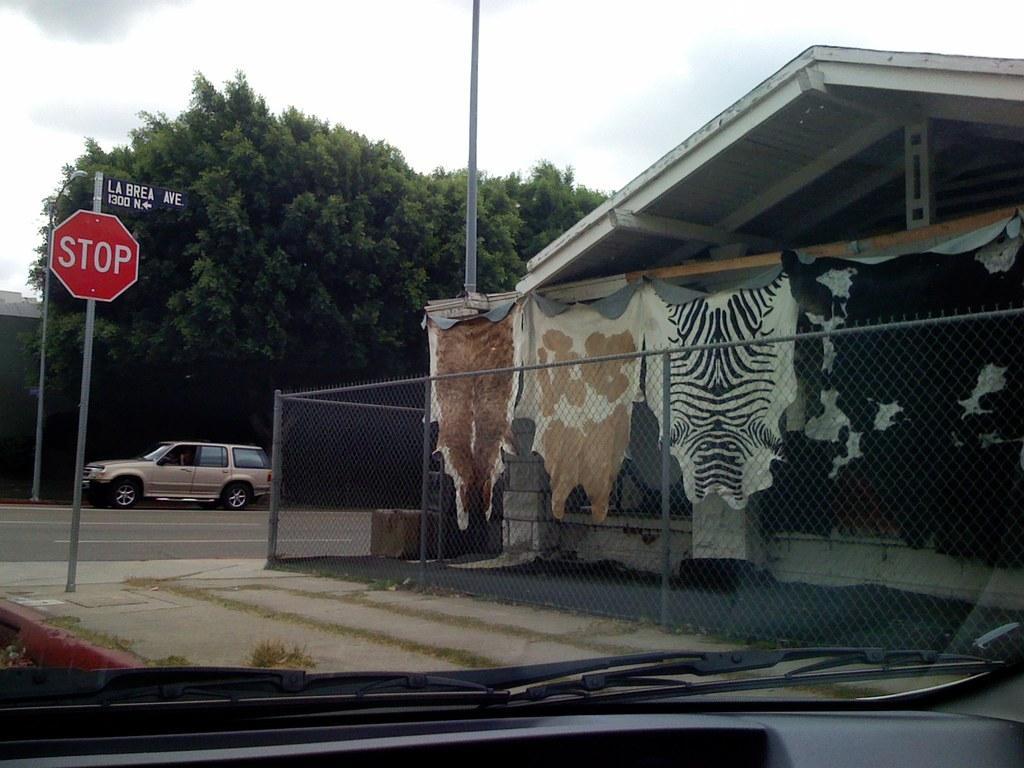Describe this image in one or two sentences. In this picture we can see a vehicle on the road, poles, sign boards, fences, clothes, trees, shed and some objects and in the background we can see the sky. 